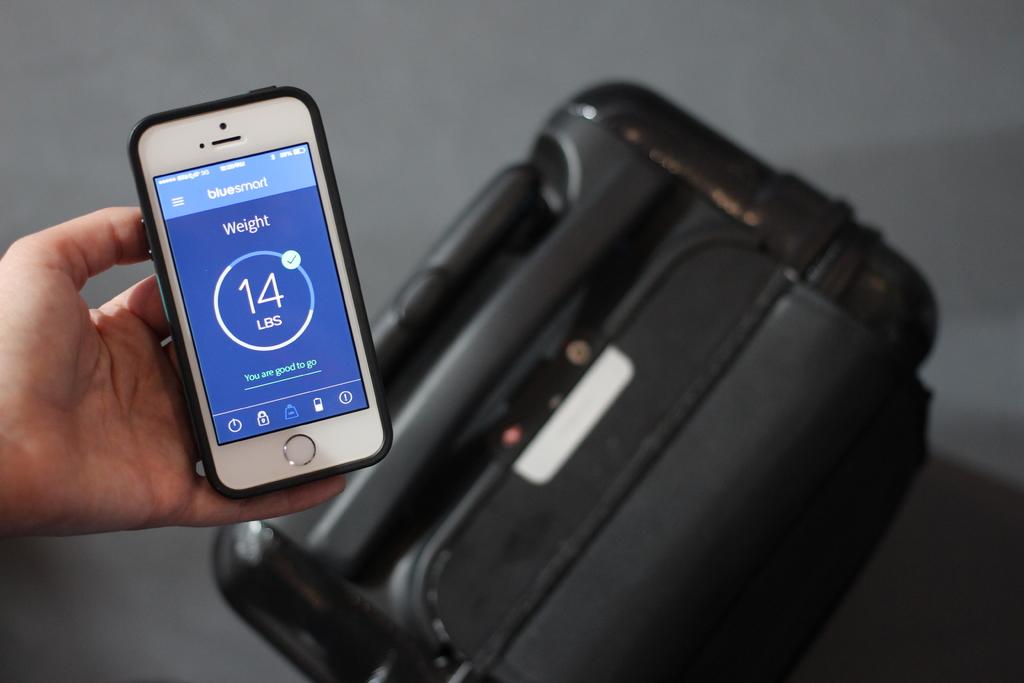What app is being used?
Give a very brief answer. Bluesmart. How many pounds?
Make the answer very short. 14. 